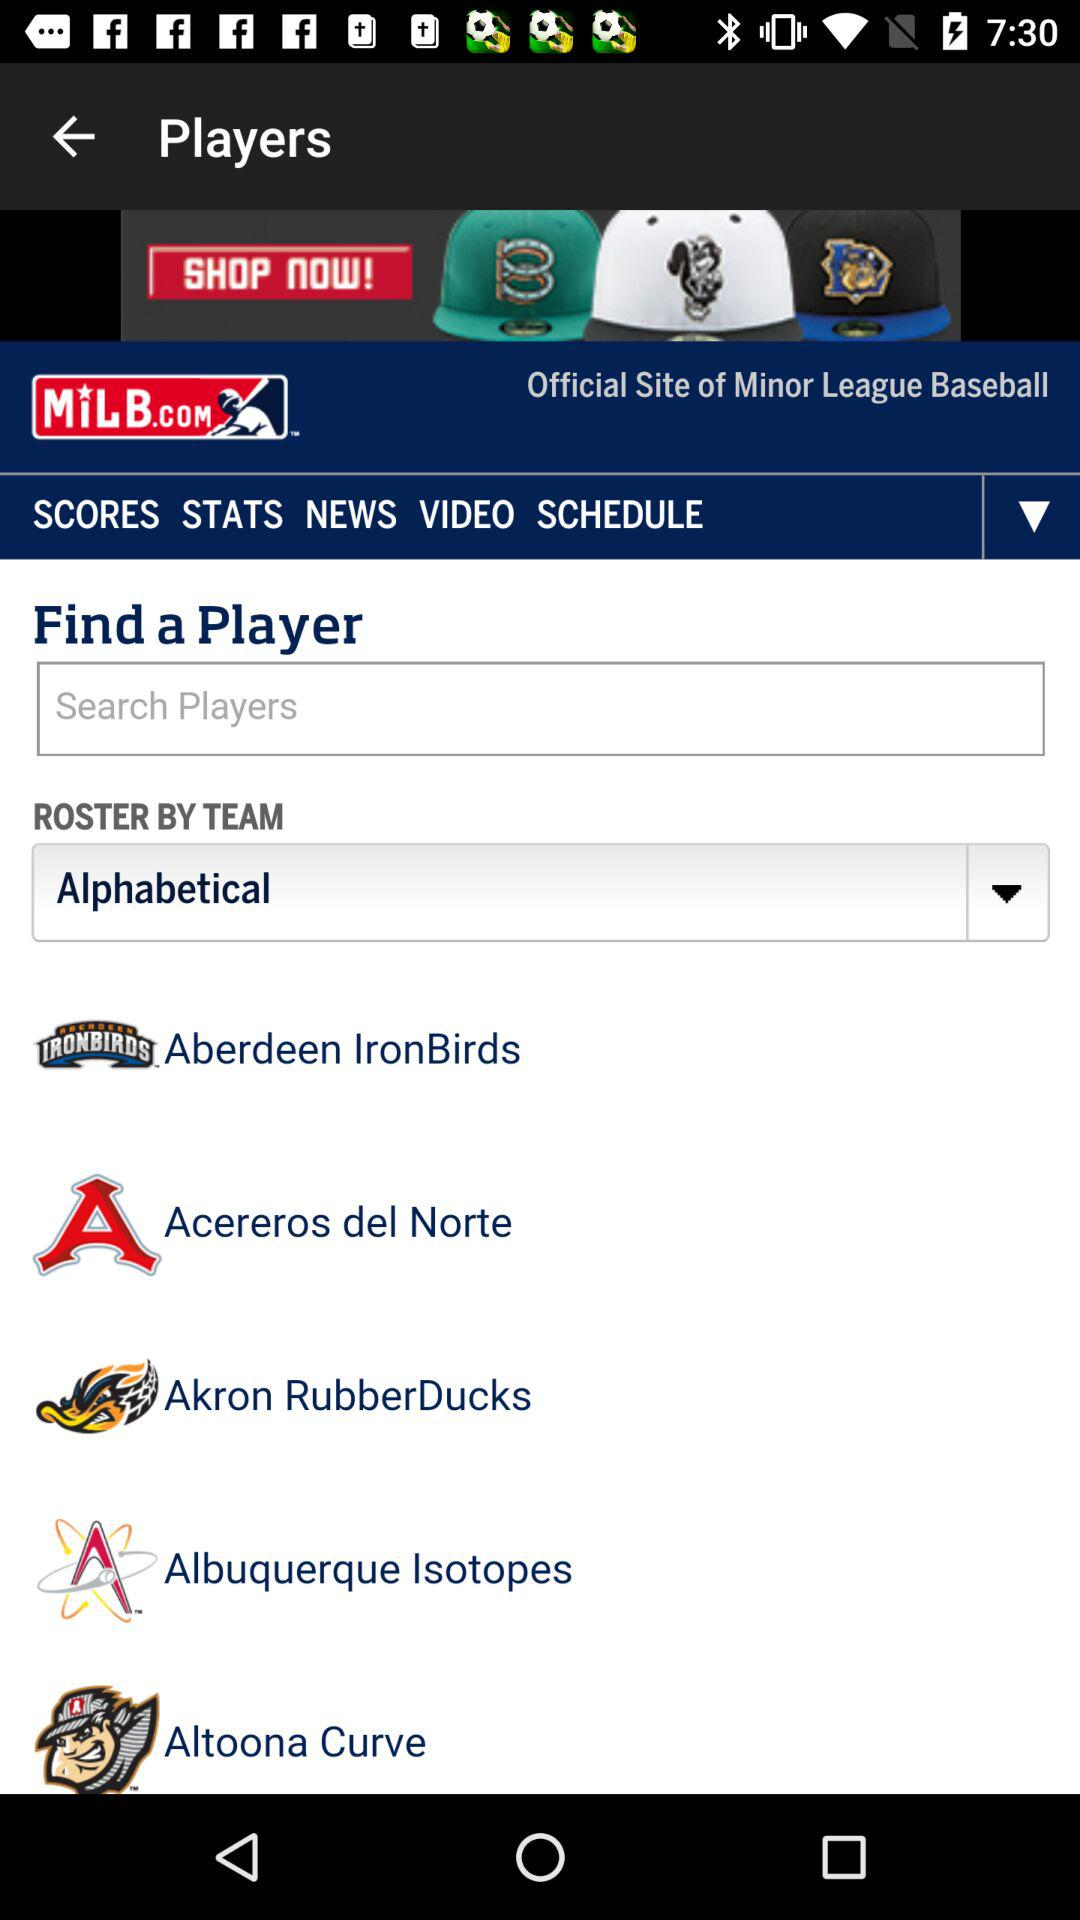What is the league name? The league name is Minor League Baseball. 